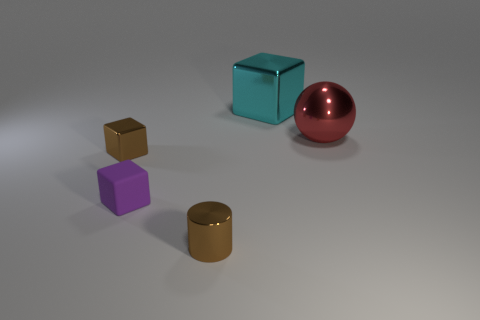Add 4 tiny purple matte objects. How many objects exist? 9 Subtract all spheres. How many objects are left? 4 Add 5 tiny cyan blocks. How many tiny cyan blocks exist? 5 Subtract 0 yellow cylinders. How many objects are left? 5 Subtract all large cubes. Subtract all rubber things. How many objects are left? 3 Add 4 brown shiny blocks. How many brown shiny blocks are left? 5 